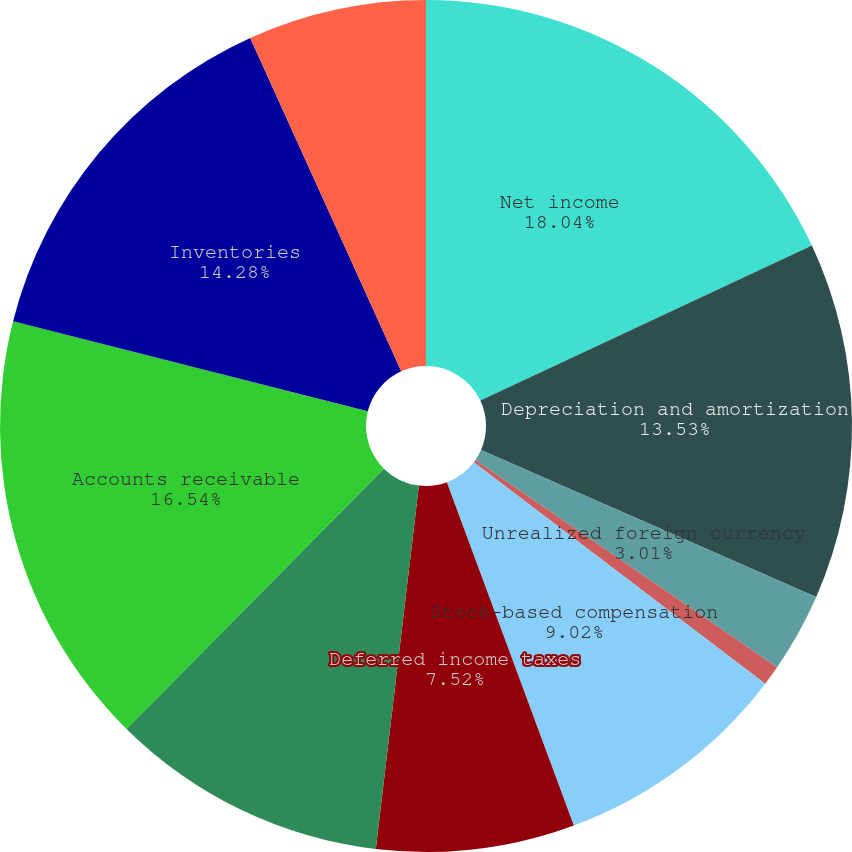Convert chart to OTSL. <chart><loc_0><loc_0><loc_500><loc_500><pie_chart><fcel>Net income<fcel>Depreciation and amortization<fcel>Unrealized foreign currency<fcel>Loss on disposal of property<fcel>Stock-based compensation<fcel>Deferred income taxes<fcel>Changes in reserves and<fcel>Accounts receivable<fcel>Inventories<fcel>Prepaid expenses and other<nl><fcel>18.04%<fcel>13.53%<fcel>3.01%<fcel>0.76%<fcel>9.02%<fcel>7.52%<fcel>10.53%<fcel>16.54%<fcel>14.28%<fcel>6.77%<nl></chart> 